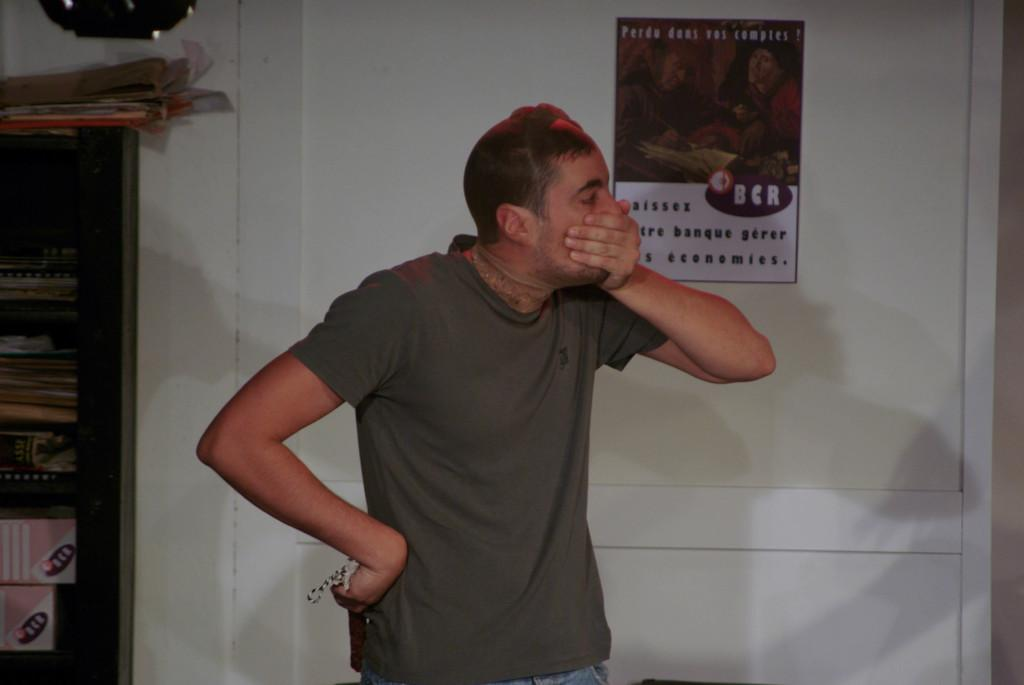<image>
Provide a brief description of the given image. A man covering his mouth with his hand in front of a BCR poster. 